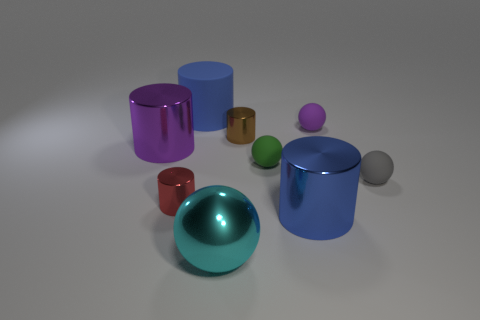Subtract 2 cylinders. How many cylinders are left? 3 Subtract all red metal cylinders. How many cylinders are left? 4 Subtract all cyan cylinders. Subtract all cyan spheres. How many cylinders are left? 5 Subtract all cylinders. How many objects are left? 4 Subtract all large red metallic cylinders. Subtract all purple rubber objects. How many objects are left? 8 Add 5 tiny green rubber things. How many tiny green rubber things are left? 6 Add 4 big purple metal objects. How many big purple metal objects exist? 5 Subtract 0 green cubes. How many objects are left? 9 